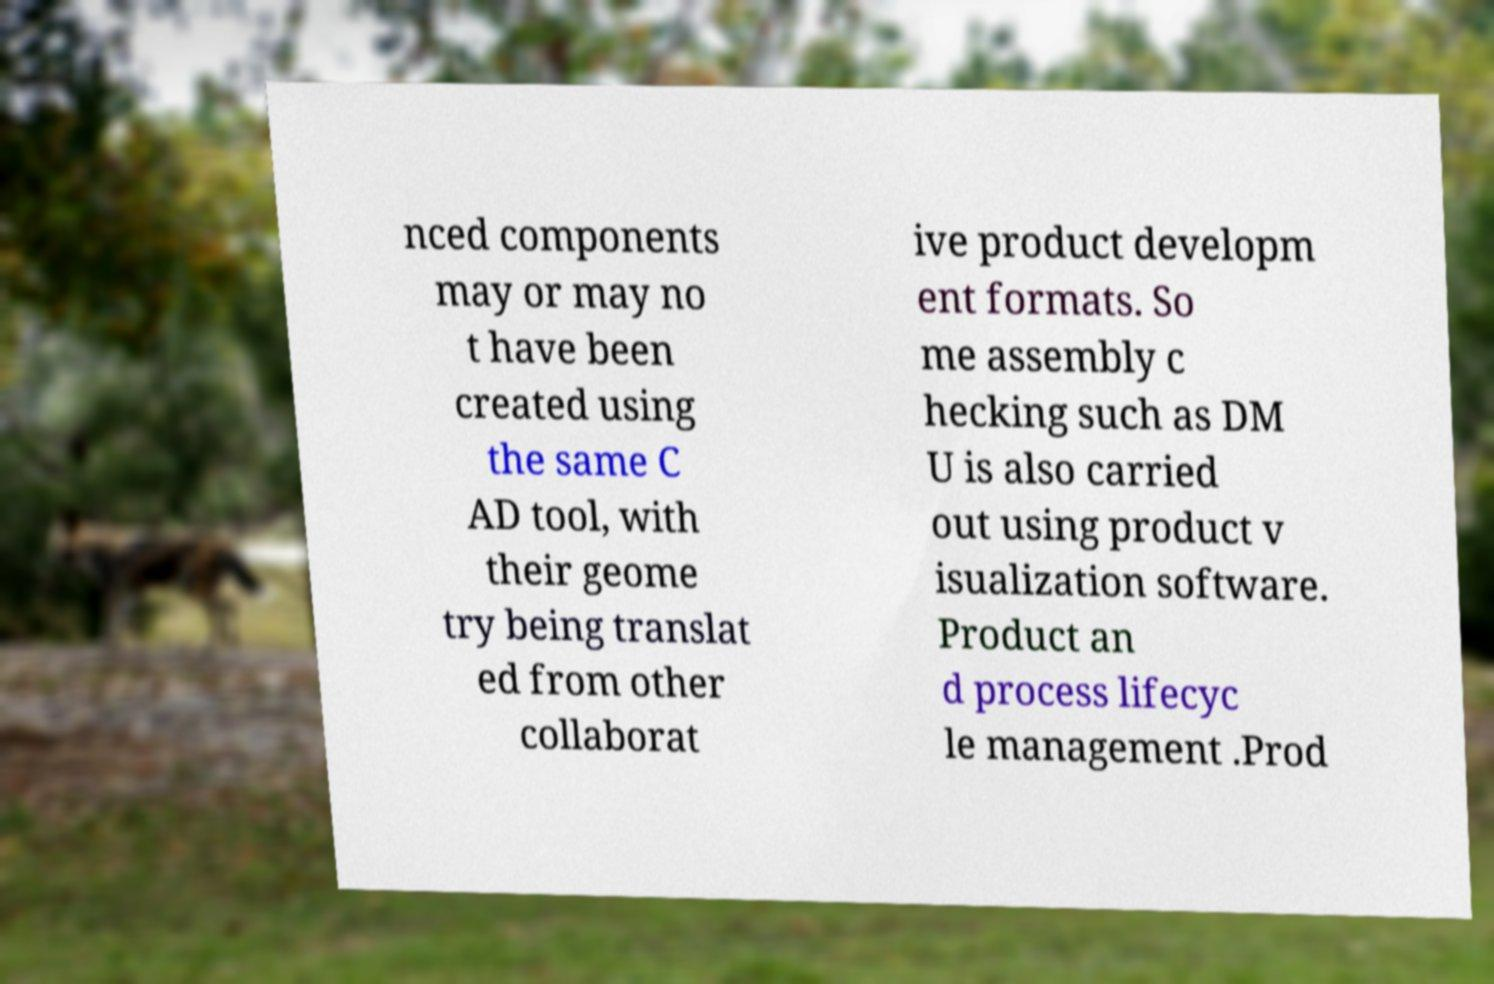There's text embedded in this image that I need extracted. Can you transcribe it verbatim? nced components may or may no t have been created using the same C AD tool, with their geome try being translat ed from other collaborat ive product developm ent formats. So me assembly c hecking such as DM U is also carried out using product v isualization software. Product an d process lifecyc le management .Prod 